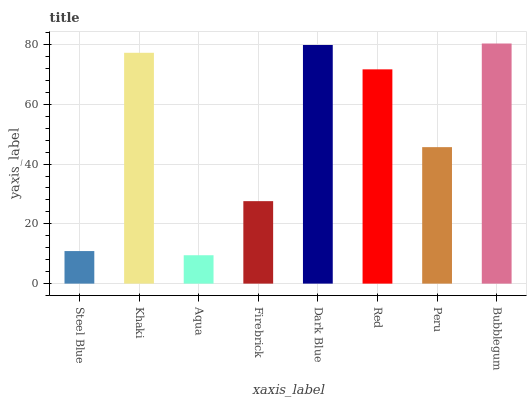Is Aqua the minimum?
Answer yes or no. Yes. Is Bubblegum the maximum?
Answer yes or no. Yes. Is Khaki the minimum?
Answer yes or no. No. Is Khaki the maximum?
Answer yes or no. No. Is Khaki greater than Steel Blue?
Answer yes or no. Yes. Is Steel Blue less than Khaki?
Answer yes or no. Yes. Is Steel Blue greater than Khaki?
Answer yes or no. No. Is Khaki less than Steel Blue?
Answer yes or no. No. Is Red the high median?
Answer yes or no. Yes. Is Peru the low median?
Answer yes or no. Yes. Is Khaki the high median?
Answer yes or no. No. Is Red the low median?
Answer yes or no. No. 